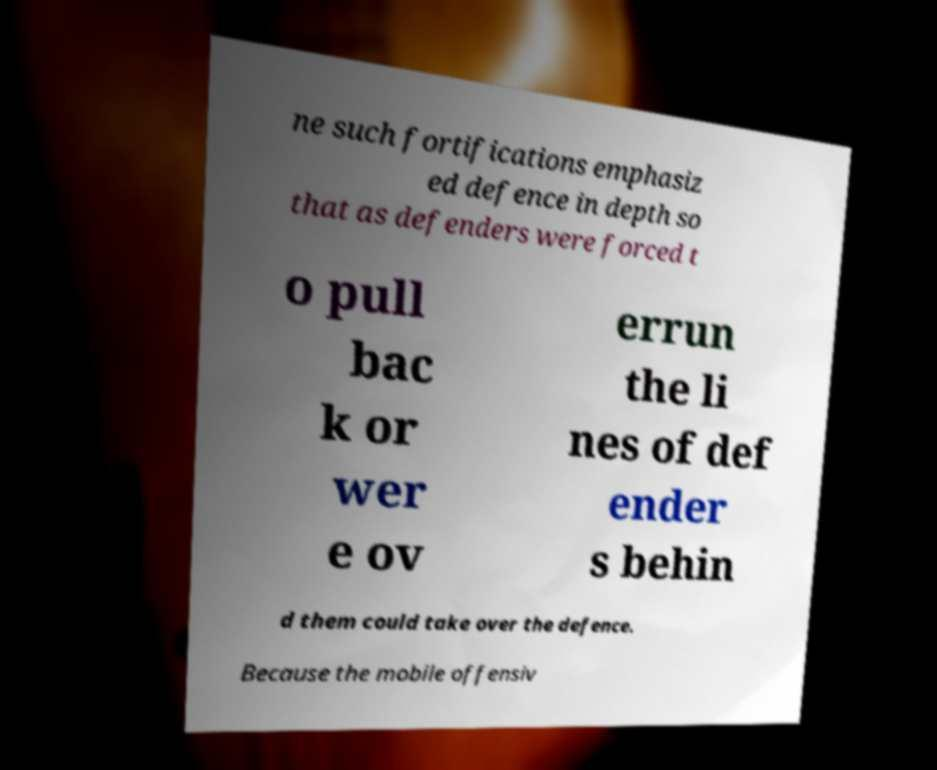Can you accurately transcribe the text from the provided image for me? ne such fortifications emphasiz ed defence in depth so that as defenders were forced t o pull bac k or wer e ov errun the li nes of def ender s behin d them could take over the defence. Because the mobile offensiv 